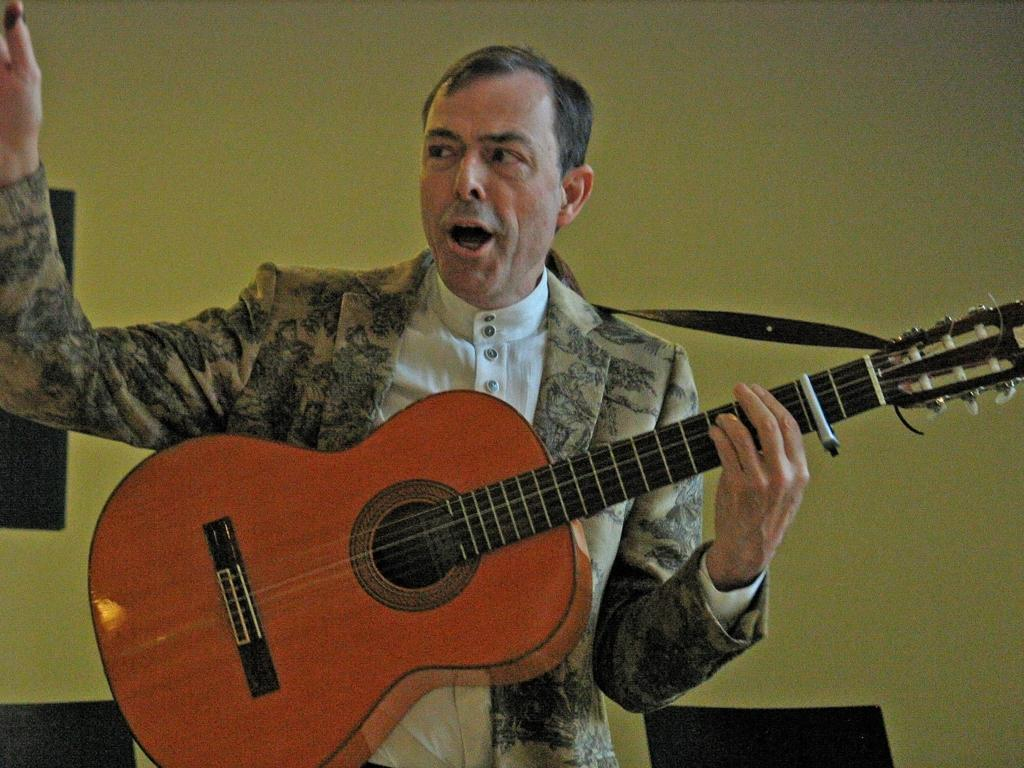Who is the main subject in the image? There is a man in the image. What is the man holding in the image? The man is holding a guitar. What might the man be doing in the image? The man appears to be talking. What is the man wearing in the image? The man is wearing a blazer. What else can be seen in the image besides the man? There are chairs in the image. What color is the toothbrush in the image? There is no toothbrush present in the image. What type of stream can be seen in the background of the image? There is no stream visible in the image; it is an indoor setting with a man, a guitar, and chairs. 